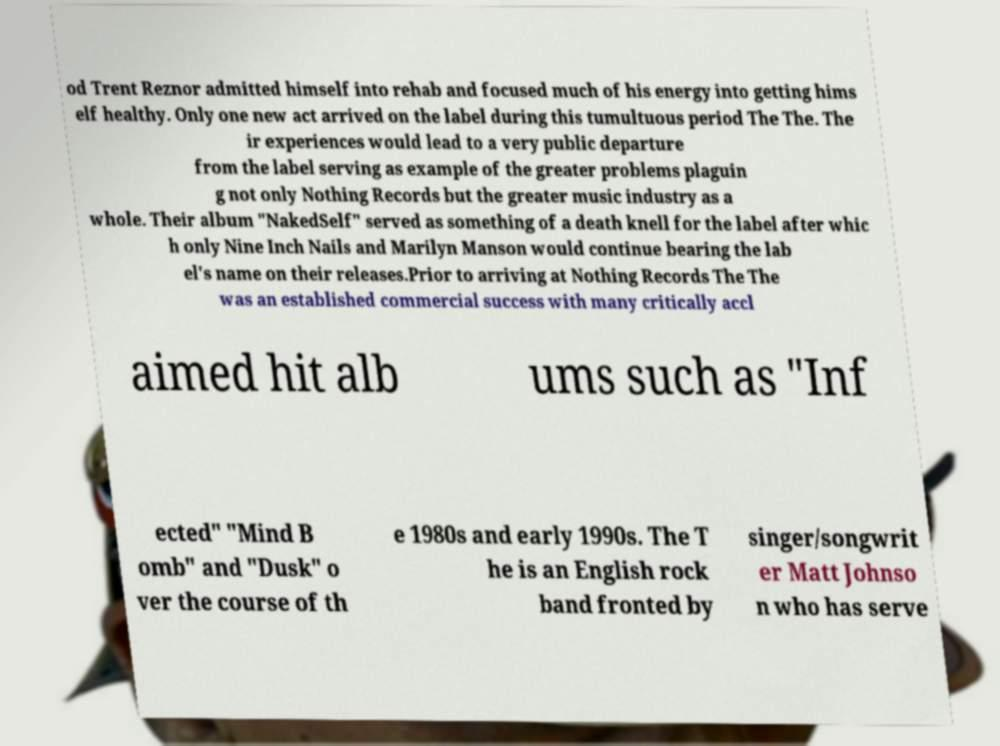Please identify and transcribe the text found in this image. od Trent Reznor admitted himself into rehab and focused much of his energy into getting hims elf healthy. Only one new act arrived on the label during this tumultuous period The The. The ir experiences would lead to a very public departure from the label serving as example of the greater problems plaguin g not only Nothing Records but the greater music industry as a whole. Their album "NakedSelf" served as something of a death knell for the label after whic h only Nine Inch Nails and Marilyn Manson would continue bearing the lab el's name on their releases.Prior to arriving at Nothing Records The The was an established commercial success with many critically accl aimed hit alb ums such as "Inf ected" "Mind B omb" and "Dusk" o ver the course of th e 1980s and early 1990s. The T he is an English rock band fronted by singer/songwrit er Matt Johnso n who has serve 